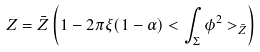<formula> <loc_0><loc_0><loc_500><loc_500>Z = \bar { Z } \left ( 1 - 2 \pi \xi ( 1 - \alpha ) < \int _ { \Sigma } \phi ^ { 2 } > _ { \bar { Z } } \right )</formula> 